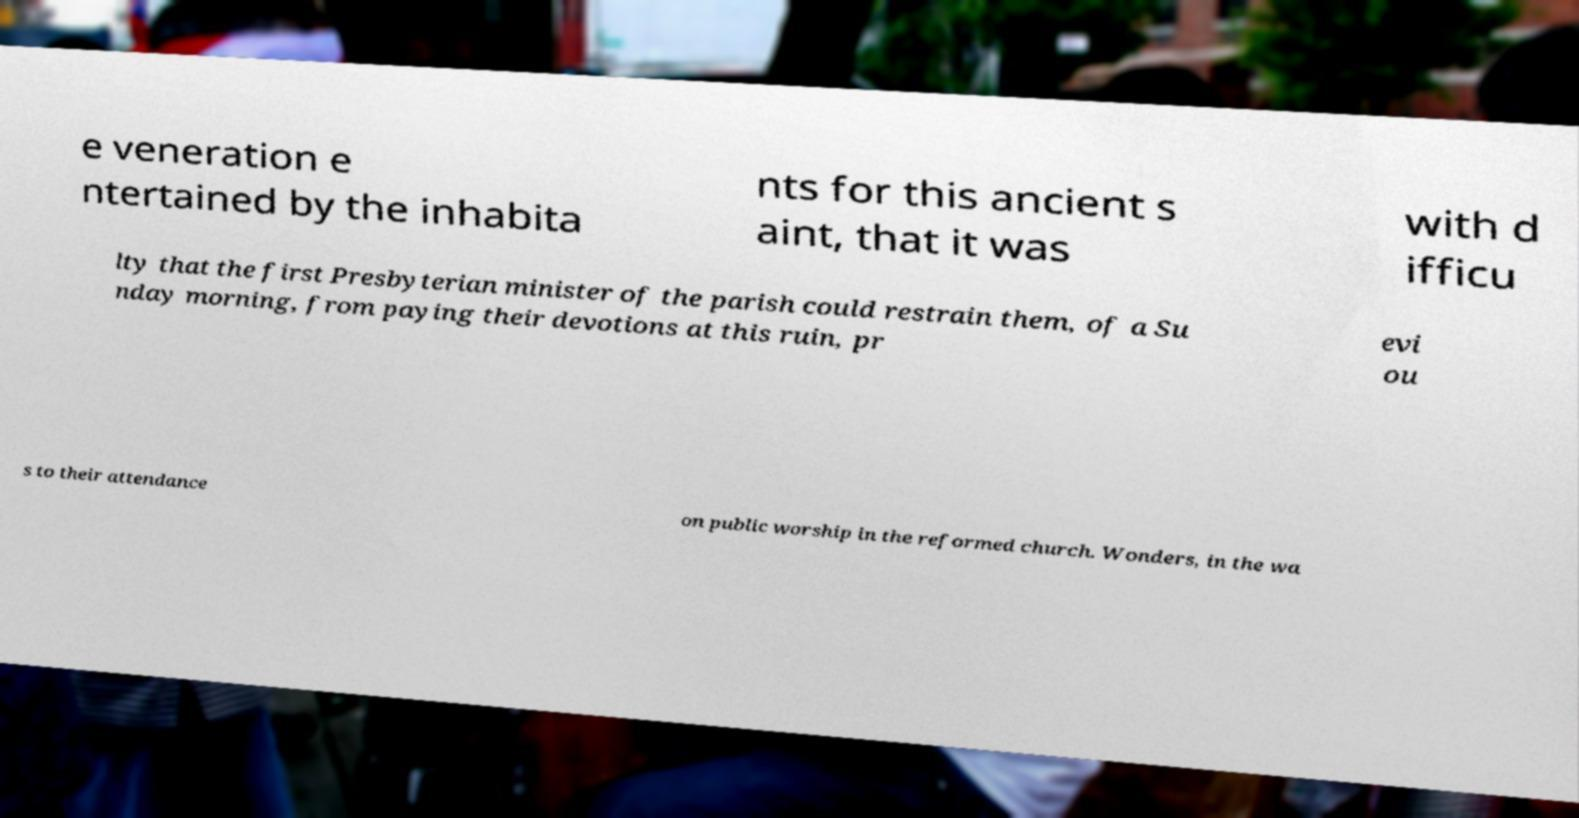Could you extract and type out the text from this image? e veneration e ntertained by the inhabita nts for this ancient s aint, that it was with d ifficu lty that the first Presbyterian minister of the parish could restrain them, of a Su nday morning, from paying their devotions at this ruin, pr evi ou s to their attendance on public worship in the reformed church. Wonders, in the wa 